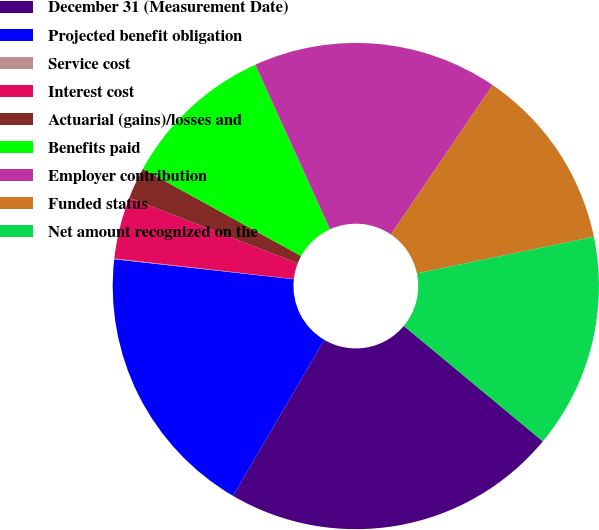Convert chart to OTSL. <chart><loc_0><loc_0><loc_500><loc_500><pie_chart><fcel>December 31 (Measurement Date)<fcel>Projected benefit obligation<fcel>Service cost<fcel>Interest cost<fcel>Actuarial (gains)/losses and<fcel>Benefits paid<fcel>Employer contribution<fcel>Funded status<fcel>Net amount recognized on the<nl><fcel>22.4%<fcel>18.33%<fcel>0.05%<fcel>4.11%<fcel>2.08%<fcel>10.21%<fcel>16.3%<fcel>12.24%<fcel>14.27%<nl></chart> 